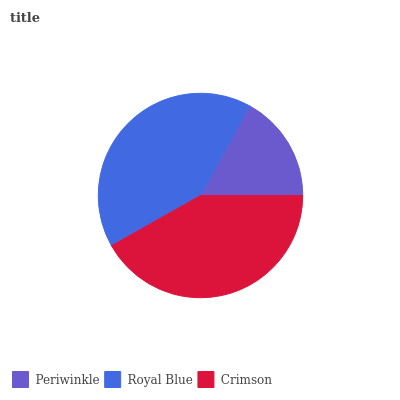Is Periwinkle the minimum?
Answer yes or no. Yes. Is Crimson the maximum?
Answer yes or no. Yes. Is Royal Blue the minimum?
Answer yes or no. No. Is Royal Blue the maximum?
Answer yes or no. No. Is Royal Blue greater than Periwinkle?
Answer yes or no. Yes. Is Periwinkle less than Royal Blue?
Answer yes or no. Yes. Is Periwinkle greater than Royal Blue?
Answer yes or no. No. Is Royal Blue less than Periwinkle?
Answer yes or no. No. Is Royal Blue the high median?
Answer yes or no. Yes. Is Royal Blue the low median?
Answer yes or no. Yes. Is Crimson the high median?
Answer yes or no. No. Is Periwinkle the low median?
Answer yes or no. No. 